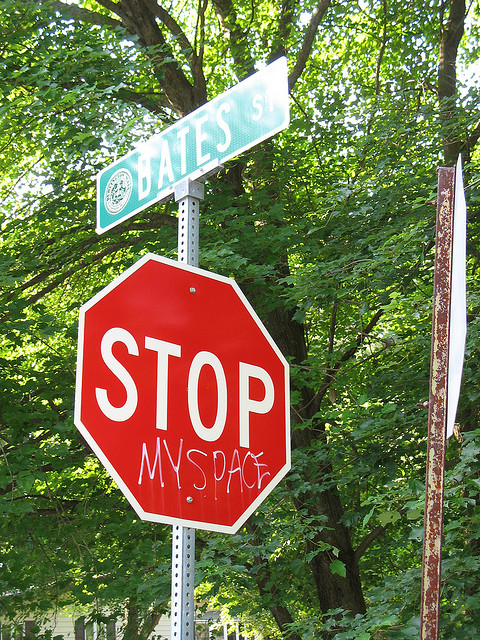Read and extract the text from this image. BATES STOP MY SPACE ST 